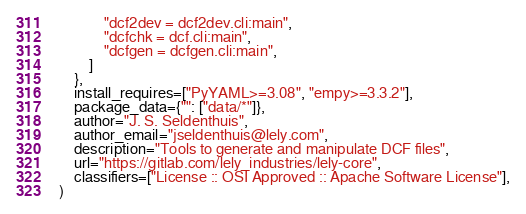Convert code to text. <code><loc_0><loc_0><loc_500><loc_500><_Python_>            "dcf2dev = dcf2dev.cli:main",
            "dcfchk = dcf.cli:main",
            "dcfgen = dcfgen.cli:main",
        ]
    },
    install_requires=["PyYAML>=3.08", "empy>=3.3.2"],
    package_data={"": ["data/*"]},
    author="J. S. Seldenthuis",
    author_email="jseldenthuis@lely.com",
    description="Tools to generate and manipulate DCF files",
    url="https://gitlab.com/lely_industries/lely-core",
    classifiers=["License :: OSI Approved :: Apache Software License"],
)
</code> 